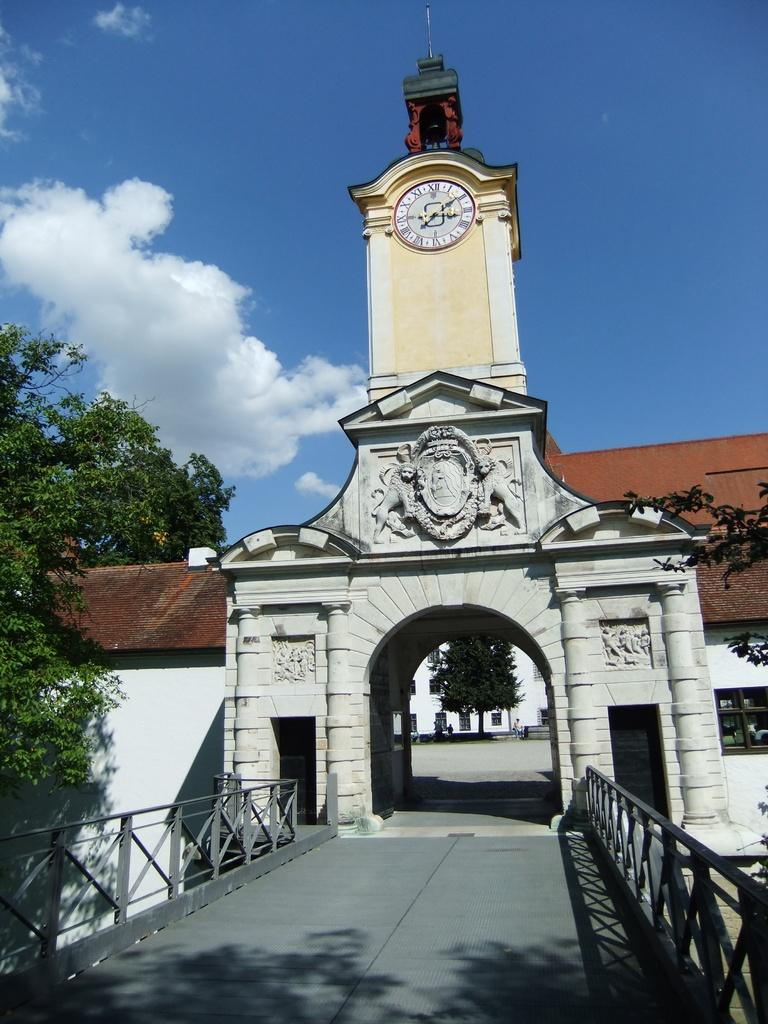What type of structure can be seen in the image? There is an arch in the image. What is located above the arch? There is a clock above the arch. What is in front of the arch? There is a bridge in front of the arch. What can be seen in the background of the image? Trees are visible in the background of the image. What is visible in the sky in the image? The sky is visible in the image, and clouds are present. What year is the brother's birthday being celebrated in the image? There is no brother or birthday celebration present in the image. 